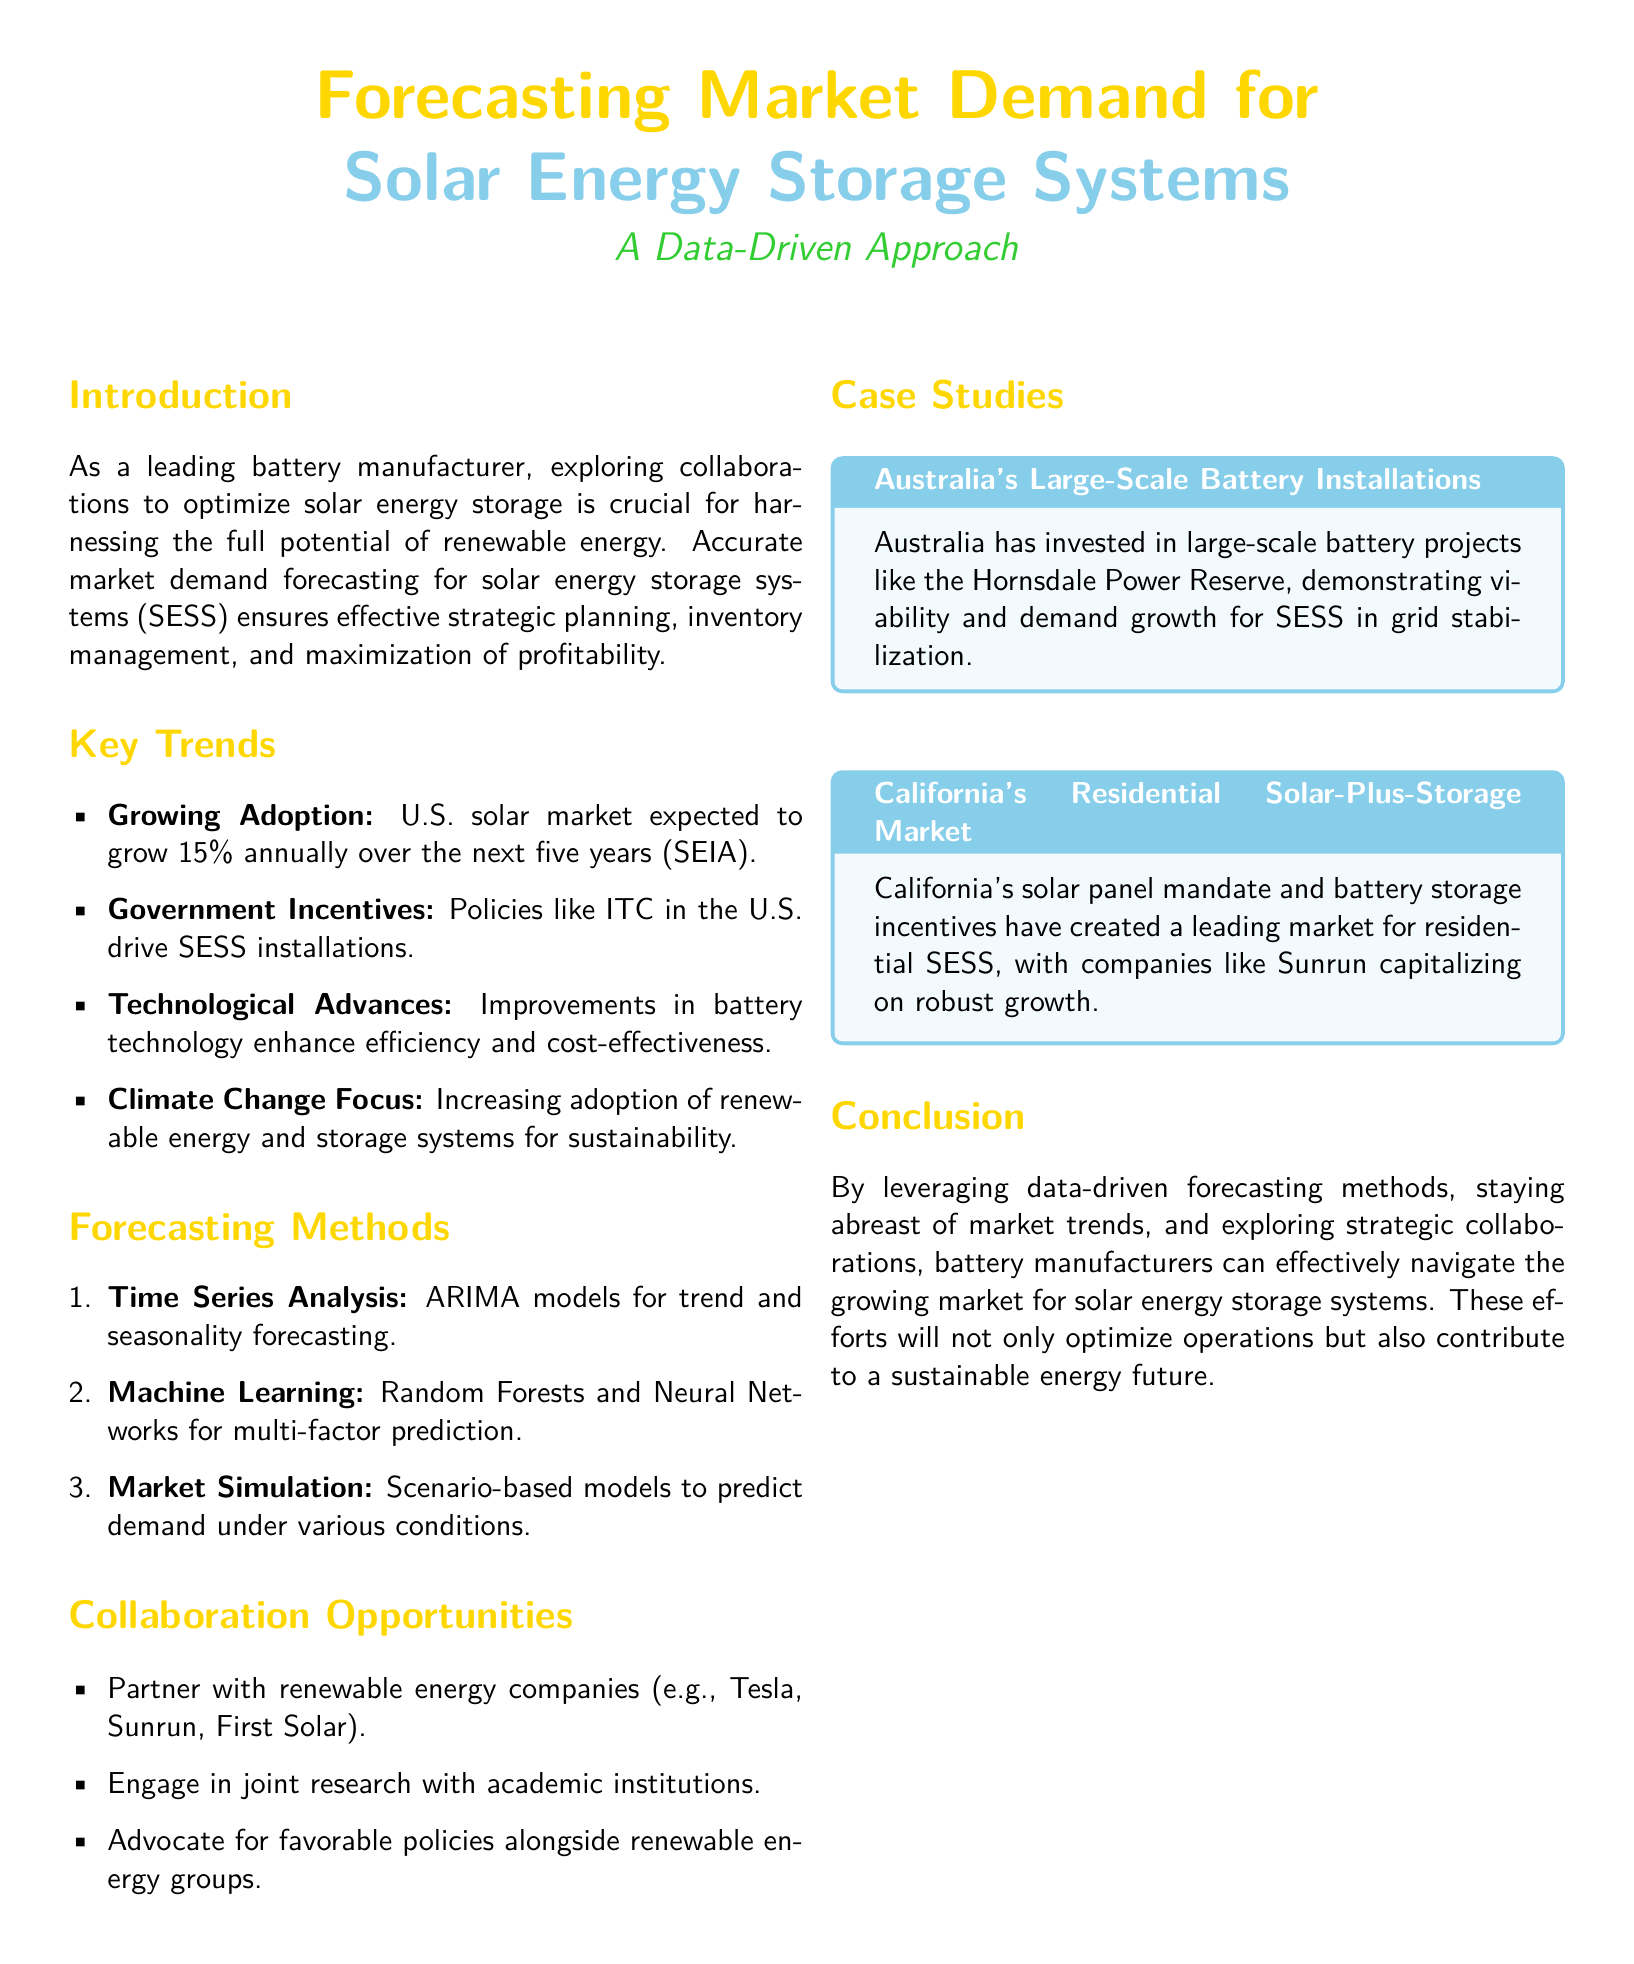what is the annual growth rate of the U.S. solar market? The document states that the U.S. solar market is expected to grow 15% annually over the next five years.
Answer: 15% what is one key governmental policy driving SESS installations in the U.S.? The document mentions the ITC as a policy driving SESS installations.
Answer: ITC name one forecasting method mentioned in the document. The document lists several methods, one of which is Time Series Analysis.
Answer: Time Series Analysis which country is highlighted for its large-scale battery installations? Australia is mentioned in the case study about large-scale battery installations.
Answer: Australia what type of analysis uses ARIMA models? The document states that Time Series Analysis uses ARIMA models for forecasting.
Answer: Time Series Analysis which market is leading in residential solar-plus-storage according to the document? The document specifies California as the leading market for residential SESS.
Answer: California what is a benefit of collaborating with renewable energy companies? The document emphasizes that partnering can optimize solar energy storage operations.
Answer: Optimize operations name a company mentioned that engages in residential SESS. Sunrun is identified as a company capitalizing on growth in California's market.
Answer: Sunrun what is the purpose of using scenario-based models? The document describes that scenario-based models are used to predict demand under various conditions.
Answer: Predict demand 